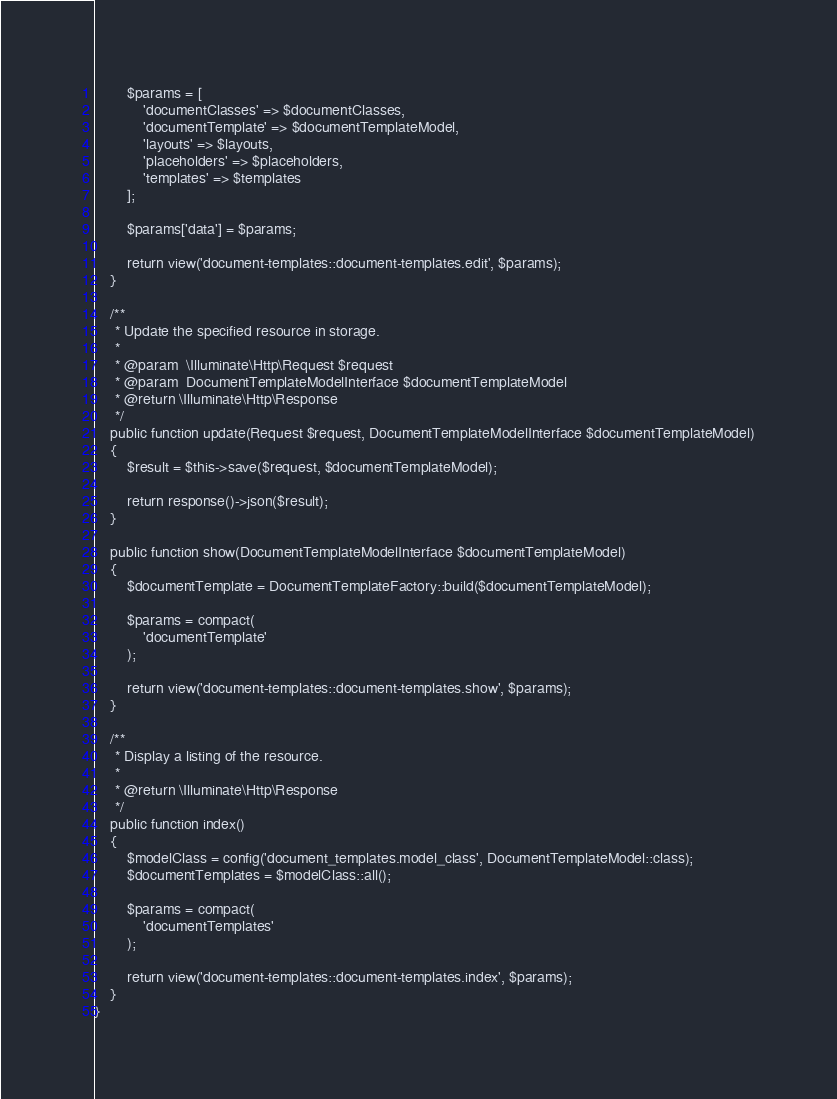Convert code to text. <code><loc_0><loc_0><loc_500><loc_500><_PHP_>
        $params = [
            'documentClasses' => $documentClasses,
            'documentTemplate' => $documentTemplateModel,
            'layouts' => $layouts,
            'placeholders' => $placeholders,
            'templates' => $templates
        ];

        $params['data'] = $params;

        return view('document-templates::document-templates.edit', $params);
    }

    /**
     * Update the specified resource in storage.
     *
     * @param  \Illuminate\Http\Request $request
     * @param  DocumentTemplateModelInterface $documentTemplateModel
     * @return \Illuminate\Http\Response
     */
    public function update(Request $request, DocumentTemplateModelInterface $documentTemplateModel)
    {
        $result = $this->save($request, $documentTemplateModel);

        return response()->json($result);
    }

    public function show(DocumentTemplateModelInterface $documentTemplateModel)
    {
        $documentTemplate = DocumentTemplateFactory::build($documentTemplateModel);

        $params = compact(
            'documentTemplate'
        );

        return view('document-templates::document-templates.show', $params);
    }

    /**
     * Display a listing of the resource.
     *
     * @return \Illuminate\Http\Response
     */
    public function index()
    {
        $modelClass = config('document_templates.model_class', DocumentTemplateModel::class);
        $documentTemplates = $modelClass::all();

        $params = compact(
            'documentTemplates'
        );

        return view('document-templates::document-templates.index', $params);
    }
}
</code> 